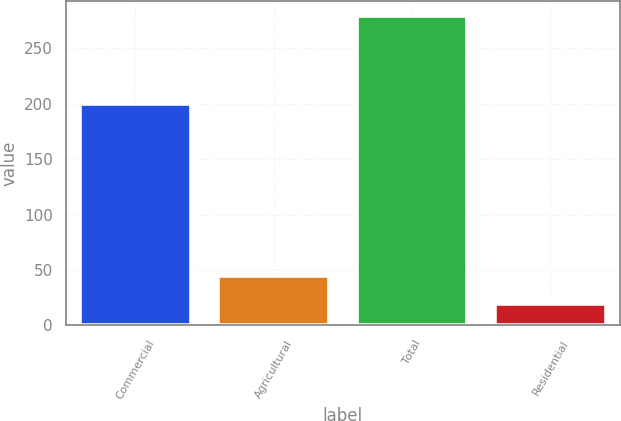<chart> <loc_0><loc_0><loc_500><loc_500><bar_chart><fcel>Commercial<fcel>Agricultural<fcel>Total<fcel>Residential<nl><fcel>200<fcel>45<fcel>279<fcel>19<nl></chart> 